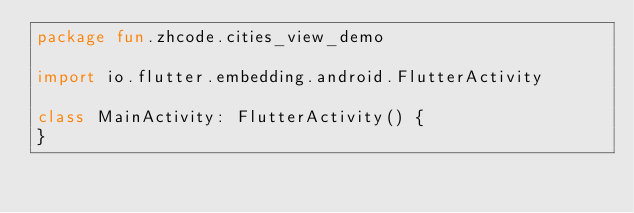Convert code to text. <code><loc_0><loc_0><loc_500><loc_500><_Kotlin_>package fun.zhcode.cities_view_demo

import io.flutter.embedding.android.FlutterActivity

class MainActivity: FlutterActivity() {
}
</code> 